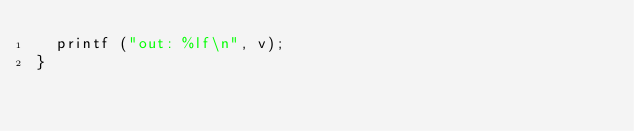<code> <loc_0><loc_0><loc_500><loc_500><_C++_>  printf ("out: %lf\n", v);
}
</code> 